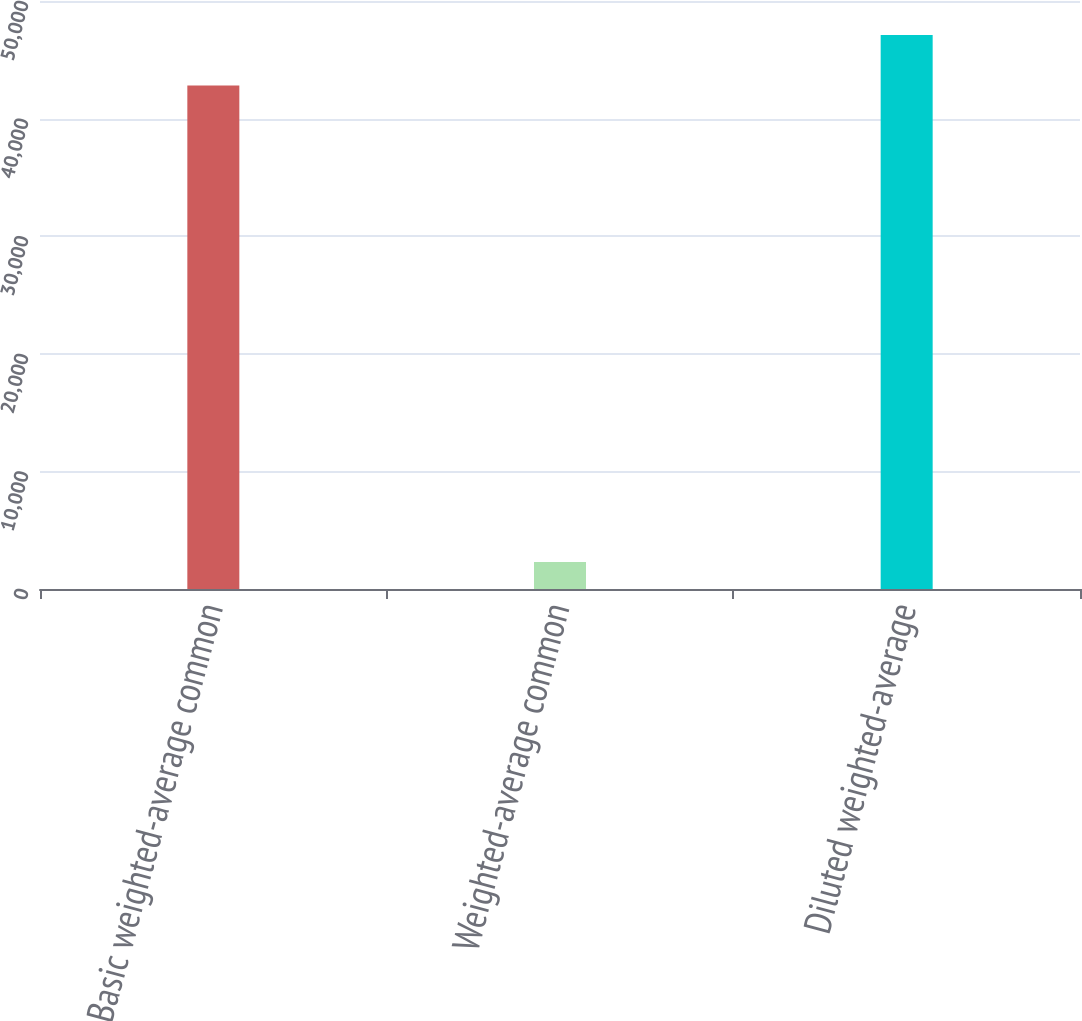Convert chart. <chart><loc_0><loc_0><loc_500><loc_500><bar_chart><fcel>Basic weighted-average common<fcel>Weighted-average common<fcel>Diluted weighted-average<nl><fcel>42824<fcel>2302<fcel>47106.4<nl></chart> 